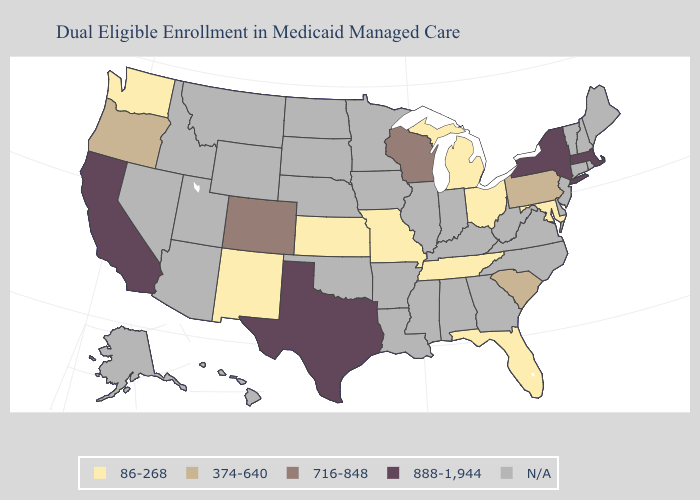What is the lowest value in the MidWest?
Quick response, please. 86-268. Among the states that border Illinois , does Missouri have the highest value?
Concise answer only. No. Among the states that border Colorado , which have the highest value?
Concise answer only. Kansas, New Mexico. What is the value of Oregon?
Be succinct. 374-640. Among the states that border Nevada , does California have the lowest value?
Concise answer only. No. Does Kansas have the lowest value in the USA?
Give a very brief answer. Yes. What is the lowest value in states that border New York?
Answer briefly. 374-640. Which states have the highest value in the USA?
Answer briefly. California, Massachusetts, New York, Texas. Name the states that have a value in the range 888-1,944?
Concise answer only. California, Massachusetts, New York, Texas. Name the states that have a value in the range 716-848?
Give a very brief answer. Colorado, Wisconsin. Does Pennsylvania have the highest value in the Northeast?
Short answer required. No. What is the lowest value in states that border New York?
Quick response, please. 374-640. 